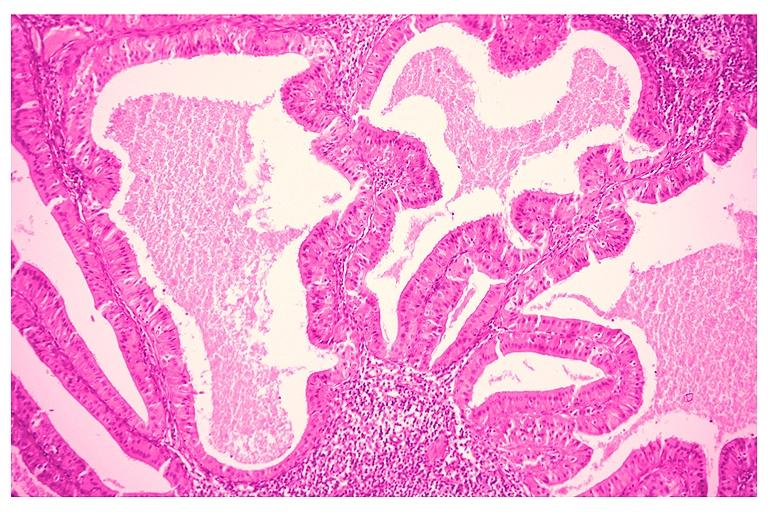does ulcer show papillary cystadenoma lymphomatosum warthins?
Answer the question using a single word or phrase. No 